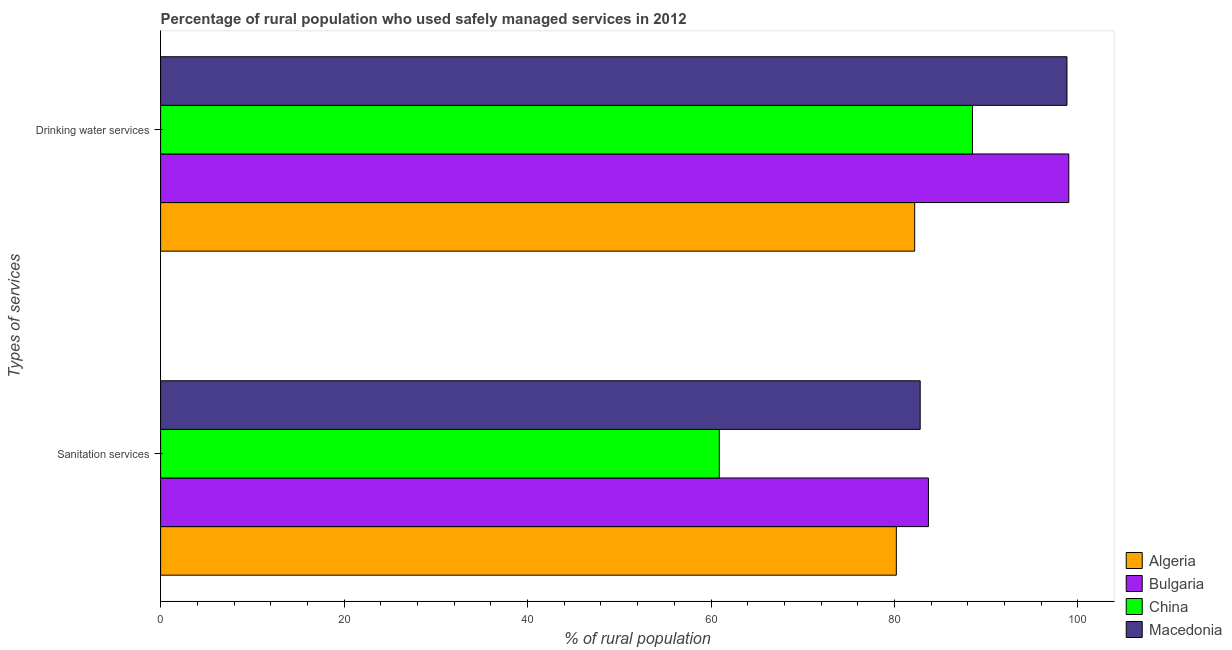How many groups of bars are there?
Give a very brief answer. 2. Are the number of bars per tick equal to the number of legend labels?
Give a very brief answer. Yes. How many bars are there on the 1st tick from the bottom?
Give a very brief answer. 4. What is the label of the 2nd group of bars from the top?
Provide a short and direct response. Sanitation services. What is the percentage of rural population who used drinking water services in Macedonia?
Keep it short and to the point. 98.8. Across all countries, what is the minimum percentage of rural population who used drinking water services?
Your answer should be compact. 82.2. In which country was the percentage of rural population who used drinking water services minimum?
Give a very brief answer. Algeria. What is the total percentage of rural population who used drinking water services in the graph?
Offer a very short reply. 368.5. What is the difference between the percentage of rural population who used drinking water services in Macedonia and that in Bulgaria?
Keep it short and to the point. -0.2. What is the difference between the percentage of rural population who used drinking water services in Macedonia and the percentage of rural population who used sanitation services in China?
Provide a succinct answer. 37.9. What is the average percentage of rural population who used sanitation services per country?
Keep it short and to the point. 76.9. What is the difference between the percentage of rural population who used drinking water services and percentage of rural population who used sanitation services in China?
Provide a short and direct response. 27.6. What is the ratio of the percentage of rural population who used drinking water services in Macedonia to that in China?
Offer a very short reply. 1.12. Is the percentage of rural population who used drinking water services in Bulgaria less than that in Macedonia?
Your answer should be compact. No. In how many countries, is the percentage of rural population who used sanitation services greater than the average percentage of rural population who used sanitation services taken over all countries?
Give a very brief answer. 3. What does the 3rd bar from the top in Sanitation services represents?
Give a very brief answer. Bulgaria. What does the 2nd bar from the bottom in Sanitation services represents?
Offer a terse response. Bulgaria. What is the difference between two consecutive major ticks on the X-axis?
Keep it short and to the point. 20. Does the graph contain any zero values?
Provide a short and direct response. No. Where does the legend appear in the graph?
Your answer should be very brief. Bottom right. How many legend labels are there?
Your answer should be compact. 4. What is the title of the graph?
Your answer should be compact. Percentage of rural population who used safely managed services in 2012. Does "Greece" appear as one of the legend labels in the graph?
Ensure brevity in your answer.  No. What is the label or title of the X-axis?
Provide a succinct answer. % of rural population. What is the label or title of the Y-axis?
Keep it short and to the point. Types of services. What is the % of rural population in Algeria in Sanitation services?
Provide a succinct answer. 80.2. What is the % of rural population of Bulgaria in Sanitation services?
Provide a short and direct response. 83.7. What is the % of rural population in China in Sanitation services?
Your response must be concise. 60.9. What is the % of rural population in Macedonia in Sanitation services?
Make the answer very short. 82.8. What is the % of rural population of Algeria in Drinking water services?
Make the answer very short. 82.2. What is the % of rural population of Bulgaria in Drinking water services?
Your answer should be compact. 99. What is the % of rural population in China in Drinking water services?
Provide a succinct answer. 88.5. What is the % of rural population in Macedonia in Drinking water services?
Your response must be concise. 98.8. Across all Types of services, what is the maximum % of rural population of Algeria?
Ensure brevity in your answer.  82.2. Across all Types of services, what is the maximum % of rural population of China?
Give a very brief answer. 88.5. Across all Types of services, what is the maximum % of rural population in Macedonia?
Make the answer very short. 98.8. Across all Types of services, what is the minimum % of rural population in Algeria?
Provide a short and direct response. 80.2. Across all Types of services, what is the minimum % of rural population of Bulgaria?
Your answer should be compact. 83.7. Across all Types of services, what is the minimum % of rural population in China?
Provide a succinct answer. 60.9. Across all Types of services, what is the minimum % of rural population of Macedonia?
Your response must be concise. 82.8. What is the total % of rural population of Algeria in the graph?
Your response must be concise. 162.4. What is the total % of rural population in Bulgaria in the graph?
Provide a succinct answer. 182.7. What is the total % of rural population of China in the graph?
Make the answer very short. 149.4. What is the total % of rural population of Macedonia in the graph?
Your answer should be compact. 181.6. What is the difference between the % of rural population in Algeria in Sanitation services and that in Drinking water services?
Make the answer very short. -2. What is the difference between the % of rural population in Bulgaria in Sanitation services and that in Drinking water services?
Your answer should be very brief. -15.3. What is the difference between the % of rural population of China in Sanitation services and that in Drinking water services?
Give a very brief answer. -27.6. What is the difference between the % of rural population in Macedonia in Sanitation services and that in Drinking water services?
Provide a succinct answer. -16. What is the difference between the % of rural population in Algeria in Sanitation services and the % of rural population in Bulgaria in Drinking water services?
Your answer should be very brief. -18.8. What is the difference between the % of rural population of Algeria in Sanitation services and the % of rural population of Macedonia in Drinking water services?
Your answer should be compact. -18.6. What is the difference between the % of rural population of Bulgaria in Sanitation services and the % of rural population of China in Drinking water services?
Provide a short and direct response. -4.8. What is the difference between the % of rural population of Bulgaria in Sanitation services and the % of rural population of Macedonia in Drinking water services?
Offer a terse response. -15.1. What is the difference between the % of rural population of China in Sanitation services and the % of rural population of Macedonia in Drinking water services?
Provide a succinct answer. -37.9. What is the average % of rural population in Algeria per Types of services?
Provide a succinct answer. 81.2. What is the average % of rural population in Bulgaria per Types of services?
Offer a terse response. 91.35. What is the average % of rural population in China per Types of services?
Your answer should be very brief. 74.7. What is the average % of rural population of Macedonia per Types of services?
Provide a succinct answer. 90.8. What is the difference between the % of rural population of Algeria and % of rural population of Bulgaria in Sanitation services?
Provide a succinct answer. -3.5. What is the difference between the % of rural population of Algeria and % of rural population of China in Sanitation services?
Keep it short and to the point. 19.3. What is the difference between the % of rural population in Bulgaria and % of rural population in China in Sanitation services?
Keep it short and to the point. 22.8. What is the difference between the % of rural population of Bulgaria and % of rural population of Macedonia in Sanitation services?
Your response must be concise. 0.9. What is the difference between the % of rural population in China and % of rural population in Macedonia in Sanitation services?
Your answer should be compact. -21.9. What is the difference between the % of rural population of Algeria and % of rural population of Bulgaria in Drinking water services?
Keep it short and to the point. -16.8. What is the difference between the % of rural population in Algeria and % of rural population in China in Drinking water services?
Ensure brevity in your answer.  -6.3. What is the difference between the % of rural population in Algeria and % of rural population in Macedonia in Drinking water services?
Your response must be concise. -16.6. What is the difference between the % of rural population of Bulgaria and % of rural population of Macedonia in Drinking water services?
Give a very brief answer. 0.2. What is the difference between the % of rural population of China and % of rural population of Macedonia in Drinking water services?
Your answer should be very brief. -10.3. What is the ratio of the % of rural population in Algeria in Sanitation services to that in Drinking water services?
Give a very brief answer. 0.98. What is the ratio of the % of rural population in Bulgaria in Sanitation services to that in Drinking water services?
Offer a very short reply. 0.85. What is the ratio of the % of rural population in China in Sanitation services to that in Drinking water services?
Your response must be concise. 0.69. What is the ratio of the % of rural population of Macedonia in Sanitation services to that in Drinking water services?
Your response must be concise. 0.84. What is the difference between the highest and the second highest % of rural population in Algeria?
Give a very brief answer. 2. What is the difference between the highest and the second highest % of rural population in China?
Your answer should be compact. 27.6. What is the difference between the highest and the second highest % of rural population of Macedonia?
Your answer should be compact. 16. What is the difference between the highest and the lowest % of rural population in Algeria?
Ensure brevity in your answer.  2. What is the difference between the highest and the lowest % of rural population of Bulgaria?
Offer a terse response. 15.3. What is the difference between the highest and the lowest % of rural population of China?
Your response must be concise. 27.6. 